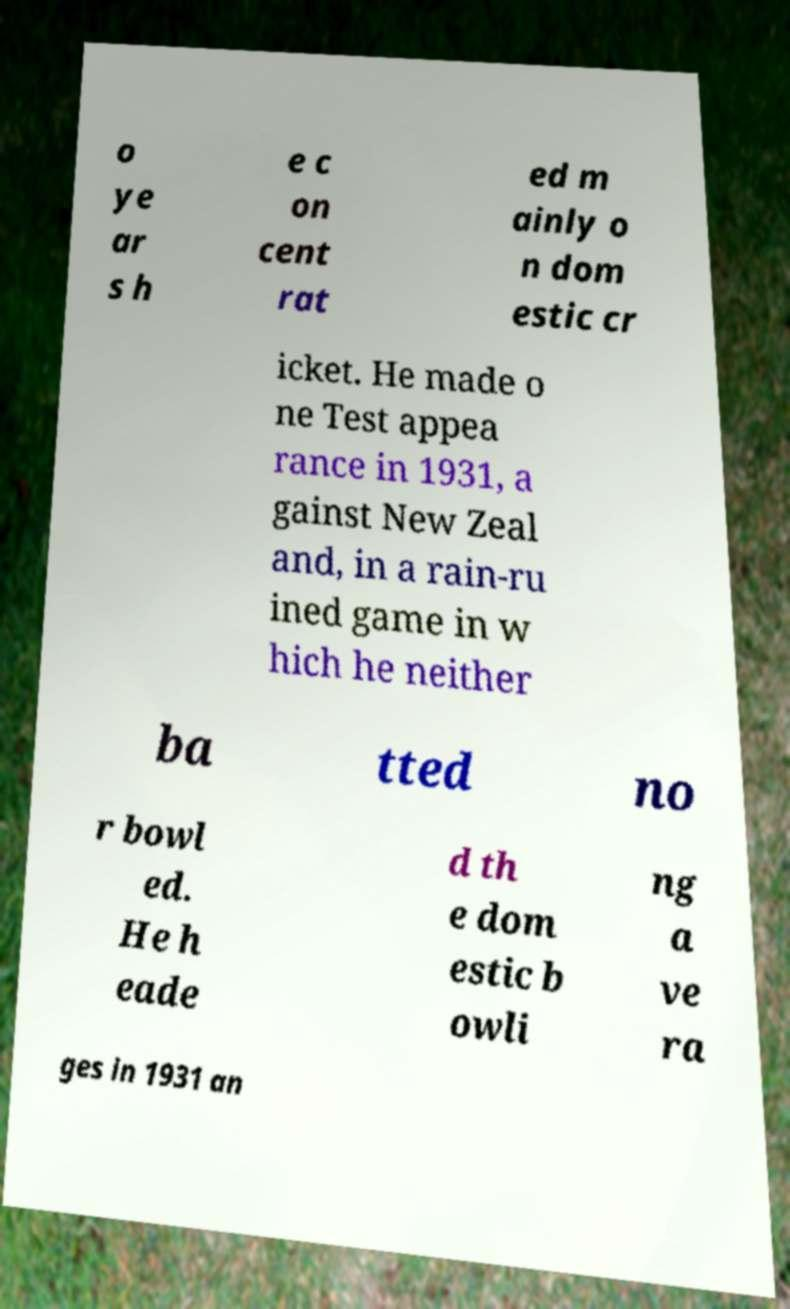Can you read and provide the text displayed in the image?This photo seems to have some interesting text. Can you extract and type it out for me? o ye ar s h e c on cent rat ed m ainly o n dom estic cr icket. He made o ne Test appea rance in 1931, a gainst New Zeal and, in a rain-ru ined game in w hich he neither ba tted no r bowl ed. He h eade d th e dom estic b owli ng a ve ra ges in 1931 an 